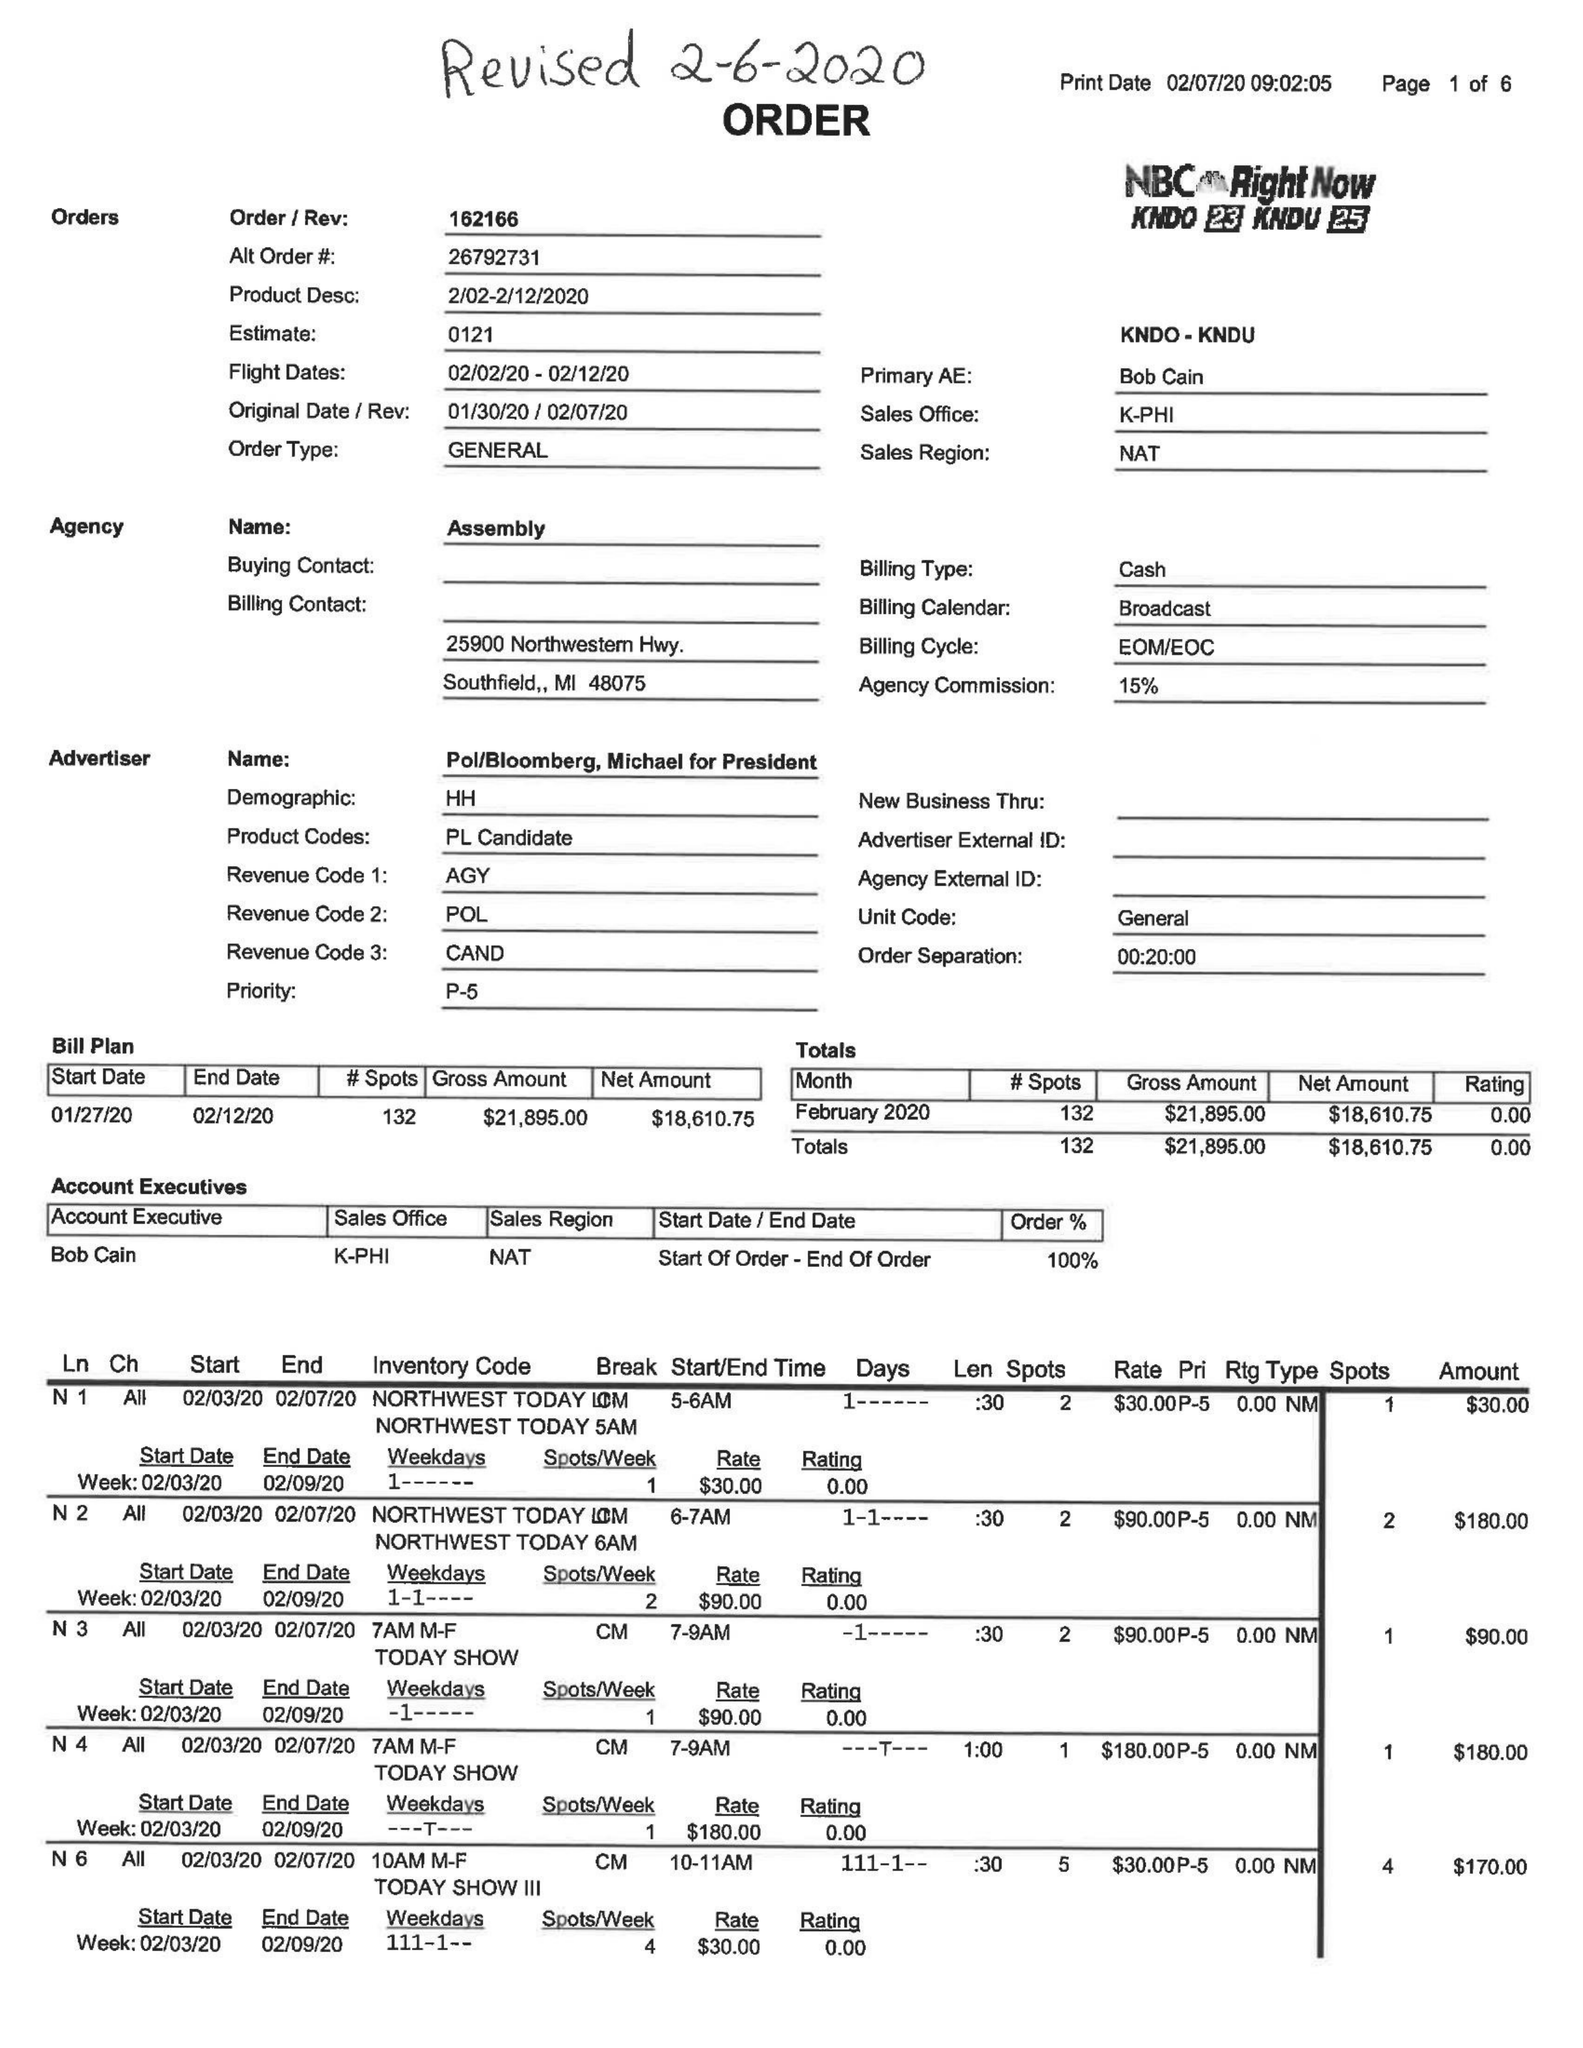What is the value for the contract_num?
Answer the question using a single word or phrase. 162166 